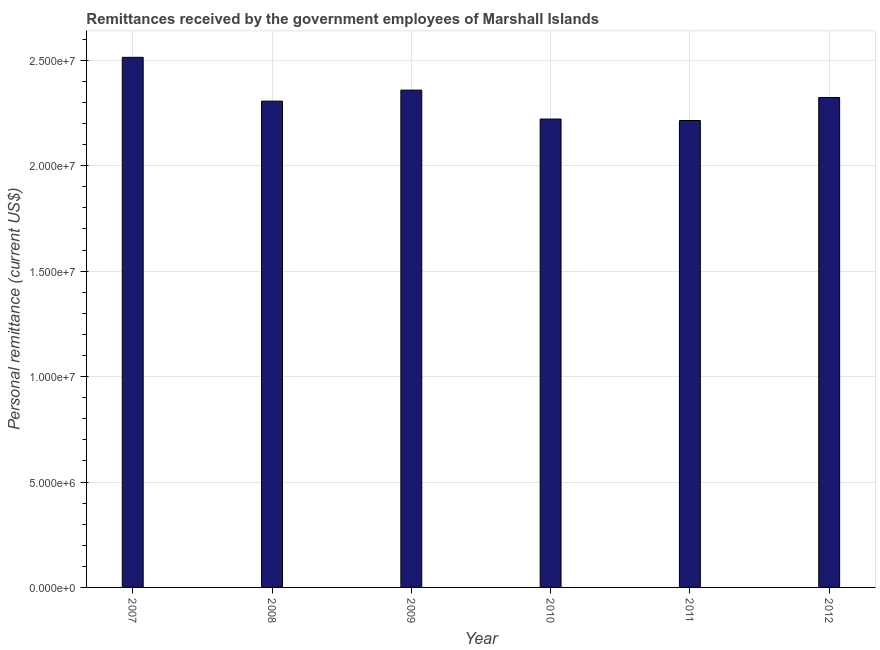Does the graph contain any zero values?
Provide a succinct answer. No. What is the title of the graph?
Your answer should be very brief. Remittances received by the government employees of Marshall Islands. What is the label or title of the Y-axis?
Ensure brevity in your answer.  Personal remittance (current US$). What is the personal remittances in 2007?
Give a very brief answer. 2.51e+07. Across all years, what is the maximum personal remittances?
Your answer should be very brief. 2.51e+07. Across all years, what is the minimum personal remittances?
Your response must be concise. 2.21e+07. What is the sum of the personal remittances?
Make the answer very short. 1.39e+08. What is the difference between the personal remittances in 2010 and 2011?
Your answer should be very brief. 6.97e+04. What is the average personal remittances per year?
Keep it short and to the point. 2.32e+07. What is the median personal remittances?
Give a very brief answer. 2.32e+07. What is the ratio of the personal remittances in 2008 to that in 2012?
Your answer should be very brief. 0.99. Is the difference between the personal remittances in 2008 and 2010 greater than the difference between any two years?
Ensure brevity in your answer.  No. What is the difference between the highest and the second highest personal remittances?
Ensure brevity in your answer.  1.56e+06. Is the sum of the personal remittances in 2010 and 2012 greater than the maximum personal remittances across all years?
Provide a short and direct response. Yes. What is the difference between the highest and the lowest personal remittances?
Ensure brevity in your answer.  3.00e+06. In how many years, is the personal remittances greater than the average personal remittances taken over all years?
Give a very brief answer. 3. Are all the bars in the graph horizontal?
Provide a succinct answer. No. What is the difference between two consecutive major ticks on the Y-axis?
Make the answer very short. 5.00e+06. What is the Personal remittance (current US$) of 2007?
Provide a short and direct response. 2.51e+07. What is the Personal remittance (current US$) of 2008?
Keep it short and to the point. 2.31e+07. What is the Personal remittance (current US$) in 2009?
Ensure brevity in your answer.  2.36e+07. What is the Personal remittance (current US$) of 2010?
Your answer should be compact. 2.22e+07. What is the Personal remittance (current US$) of 2011?
Provide a short and direct response. 2.21e+07. What is the Personal remittance (current US$) in 2012?
Make the answer very short. 2.32e+07. What is the difference between the Personal remittance (current US$) in 2007 and 2008?
Your answer should be very brief. 2.08e+06. What is the difference between the Personal remittance (current US$) in 2007 and 2009?
Offer a very short reply. 1.56e+06. What is the difference between the Personal remittance (current US$) in 2007 and 2010?
Your answer should be compact. 2.93e+06. What is the difference between the Personal remittance (current US$) in 2007 and 2011?
Provide a succinct answer. 3.00e+06. What is the difference between the Personal remittance (current US$) in 2007 and 2012?
Provide a short and direct response. 1.91e+06. What is the difference between the Personal remittance (current US$) in 2008 and 2009?
Ensure brevity in your answer.  -5.22e+05. What is the difference between the Personal remittance (current US$) in 2008 and 2010?
Provide a short and direct response. 8.50e+05. What is the difference between the Personal remittance (current US$) in 2008 and 2011?
Your response must be concise. 9.20e+05. What is the difference between the Personal remittance (current US$) in 2008 and 2012?
Your response must be concise. -1.72e+05. What is the difference between the Personal remittance (current US$) in 2009 and 2010?
Provide a succinct answer. 1.37e+06. What is the difference between the Personal remittance (current US$) in 2009 and 2011?
Provide a succinct answer. 1.44e+06. What is the difference between the Personal remittance (current US$) in 2009 and 2012?
Keep it short and to the point. 3.50e+05. What is the difference between the Personal remittance (current US$) in 2010 and 2011?
Keep it short and to the point. 6.97e+04. What is the difference between the Personal remittance (current US$) in 2010 and 2012?
Offer a terse response. -1.02e+06. What is the difference between the Personal remittance (current US$) in 2011 and 2012?
Your response must be concise. -1.09e+06. What is the ratio of the Personal remittance (current US$) in 2007 to that in 2008?
Make the answer very short. 1.09. What is the ratio of the Personal remittance (current US$) in 2007 to that in 2009?
Make the answer very short. 1.07. What is the ratio of the Personal remittance (current US$) in 2007 to that in 2010?
Ensure brevity in your answer.  1.13. What is the ratio of the Personal remittance (current US$) in 2007 to that in 2011?
Give a very brief answer. 1.14. What is the ratio of the Personal remittance (current US$) in 2007 to that in 2012?
Keep it short and to the point. 1.08. What is the ratio of the Personal remittance (current US$) in 2008 to that in 2010?
Offer a very short reply. 1.04. What is the ratio of the Personal remittance (current US$) in 2008 to that in 2011?
Provide a succinct answer. 1.04. What is the ratio of the Personal remittance (current US$) in 2008 to that in 2012?
Offer a very short reply. 0.99. What is the ratio of the Personal remittance (current US$) in 2009 to that in 2010?
Your answer should be compact. 1.06. What is the ratio of the Personal remittance (current US$) in 2009 to that in 2011?
Offer a terse response. 1.06. What is the ratio of the Personal remittance (current US$) in 2009 to that in 2012?
Make the answer very short. 1.01. What is the ratio of the Personal remittance (current US$) in 2010 to that in 2012?
Your answer should be compact. 0.96. What is the ratio of the Personal remittance (current US$) in 2011 to that in 2012?
Your response must be concise. 0.95. 